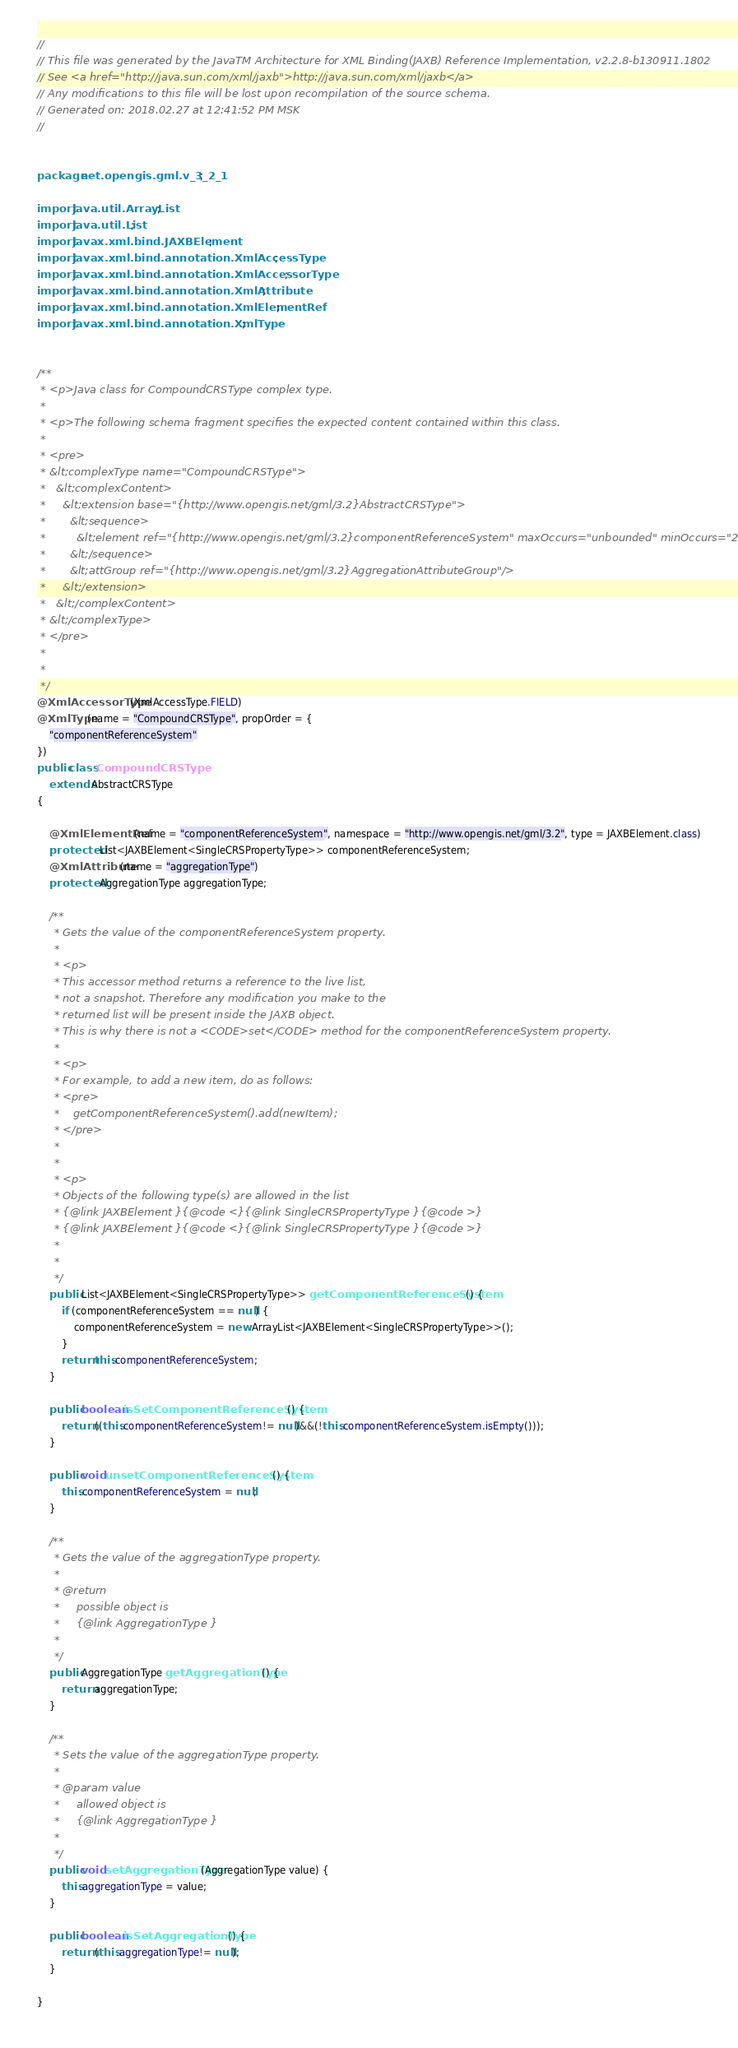<code> <loc_0><loc_0><loc_500><loc_500><_Java_>//
// This file was generated by the JavaTM Architecture for XML Binding(JAXB) Reference Implementation, v2.2.8-b130911.1802 
// See <a href="http://java.sun.com/xml/jaxb">http://java.sun.com/xml/jaxb</a> 
// Any modifications to this file will be lost upon recompilation of the source schema. 
// Generated on: 2018.02.27 at 12:41:52 PM MSK 
//


package net.opengis.gml.v_3_2_1;

import java.util.ArrayList;
import java.util.List;
import javax.xml.bind.JAXBElement;
import javax.xml.bind.annotation.XmlAccessType;
import javax.xml.bind.annotation.XmlAccessorType;
import javax.xml.bind.annotation.XmlAttribute;
import javax.xml.bind.annotation.XmlElementRef;
import javax.xml.bind.annotation.XmlType;


/**
 * <p>Java class for CompoundCRSType complex type.
 * 
 * <p>The following schema fragment specifies the expected content contained within this class.
 * 
 * <pre>
 * &lt;complexType name="CompoundCRSType">
 *   &lt;complexContent>
 *     &lt;extension base="{http://www.opengis.net/gml/3.2}AbstractCRSType">
 *       &lt;sequence>
 *         &lt;element ref="{http://www.opengis.net/gml/3.2}componentReferenceSystem" maxOccurs="unbounded" minOccurs="2"/>
 *       &lt;/sequence>
 *       &lt;attGroup ref="{http://www.opengis.net/gml/3.2}AggregationAttributeGroup"/>
 *     &lt;/extension>
 *   &lt;/complexContent>
 * &lt;/complexType>
 * </pre>
 * 
 * 
 */
@XmlAccessorType(XmlAccessType.FIELD)
@XmlType(name = "CompoundCRSType", propOrder = {
    "componentReferenceSystem"
})
public class CompoundCRSType
    extends AbstractCRSType
{

    @XmlElementRef(name = "componentReferenceSystem", namespace = "http://www.opengis.net/gml/3.2", type = JAXBElement.class)
    protected List<JAXBElement<SingleCRSPropertyType>> componentReferenceSystem;
    @XmlAttribute(name = "aggregationType")
    protected AggregationType aggregationType;

    /**
     * Gets the value of the componentReferenceSystem property.
     * 
     * <p>
     * This accessor method returns a reference to the live list,
     * not a snapshot. Therefore any modification you make to the
     * returned list will be present inside the JAXB object.
     * This is why there is not a <CODE>set</CODE> method for the componentReferenceSystem property.
     * 
     * <p>
     * For example, to add a new item, do as follows:
     * <pre>
     *    getComponentReferenceSystem().add(newItem);
     * </pre>
     * 
     * 
     * <p>
     * Objects of the following type(s) are allowed in the list
     * {@link JAXBElement }{@code <}{@link SingleCRSPropertyType }{@code >}
     * {@link JAXBElement }{@code <}{@link SingleCRSPropertyType }{@code >}
     * 
     * 
     */
    public List<JAXBElement<SingleCRSPropertyType>> getComponentReferenceSystem() {
        if (componentReferenceSystem == null) {
            componentReferenceSystem = new ArrayList<JAXBElement<SingleCRSPropertyType>>();
        }
        return this.componentReferenceSystem;
    }

    public boolean isSetComponentReferenceSystem() {
        return ((this.componentReferenceSystem!= null)&&(!this.componentReferenceSystem.isEmpty()));
    }

    public void unsetComponentReferenceSystem() {
        this.componentReferenceSystem = null;
    }

    /**
     * Gets the value of the aggregationType property.
     * 
     * @return
     *     possible object is
     *     {@link AggregationType }
     *     
     */
    public AggregationType getAggregationType() {
        return aggregationType;
    }

    /**
     * Sets the value of the aggregationType property.
     * 
     * @param value
     *     allowed object is
     *     {@link AggregationType }
     *     
     */
    public void setAggregationType(AggregationType value) {
        this.aggregationType = value;
    }

    public boolean isSetAggregationType() {
        return (this.aggregationType!= null);
    }

}
</code> 